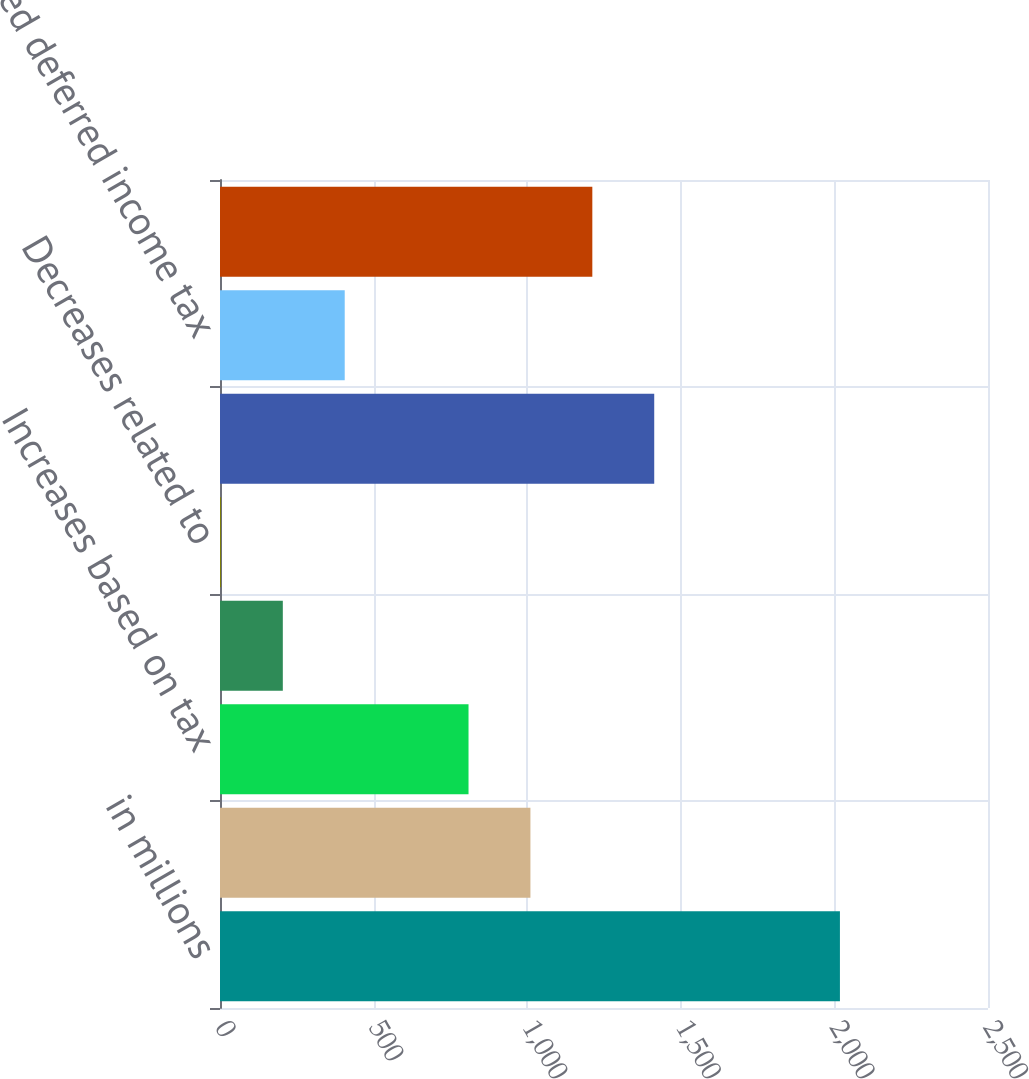Convert chart. <chart><loc_0><loc_0><loc_500><loc_500><bar_chart><fcel>in millions<fcel>Beginning balance<fcel>Increases based on tax<fcel>Decreases based on tax<fcel>Decreases related to<fcel>Ending balance<fcel>Related deferred income tax<fcel>Net unrecognized tax benefit<nl><fcel>2018<fcel>1010.5<fcel>809<fcel>204.5<fcel>3<fcel>1413.5<fcel>406<fcel>1212<nl></chart> 